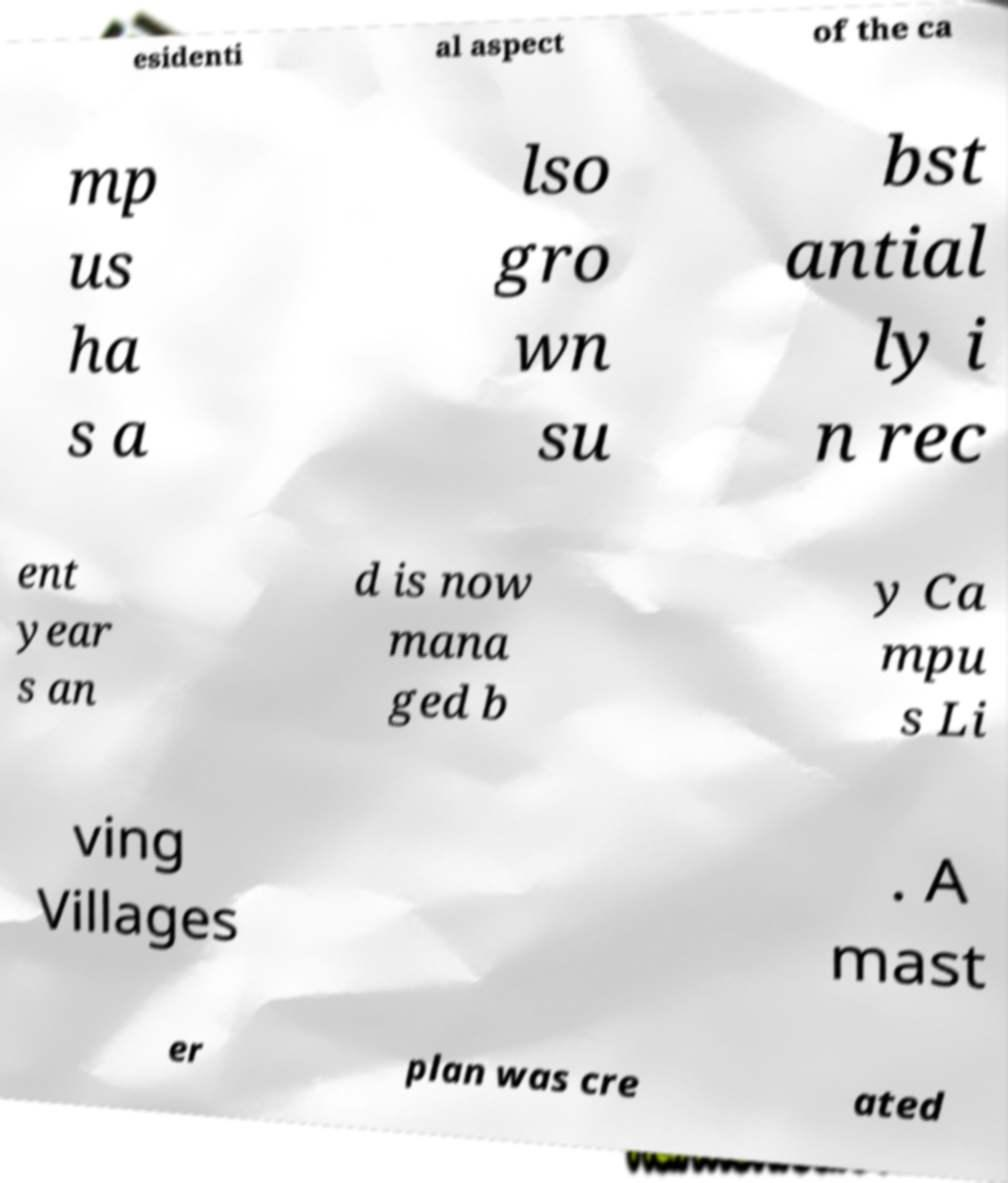Could you assist in decoding the text presented in this image and type it out clearly? esidenti al aspect of the ca mp us ha s a lso gro wn su bst antial ly i n rec ent year s an d is now mana ged b y Ca mpu s Li ving Villages . A mast er plan was cre ated 